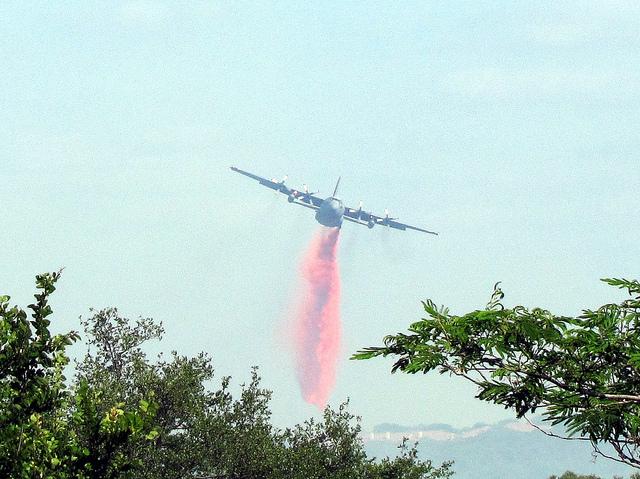Is the plane on fire?
Give a very brief answer. No. What is unusual about this photo?
Give a very brief answer. Pink smoke. What color are the trees?
Write a very short answer. Green. 